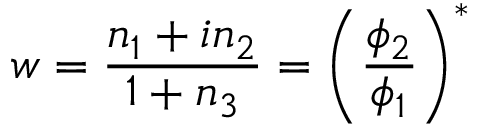<formula> <loc_0><loc_0><loc_500><loc_500>w = { \frac { n _ { 1 } + i n _ { 2 } } { 1 + n _ { 3 } } } = \left ( { \frac { \phi _ { 2 } } { \phi _ { 1 } } } \right ) ^ { * }</formula> 